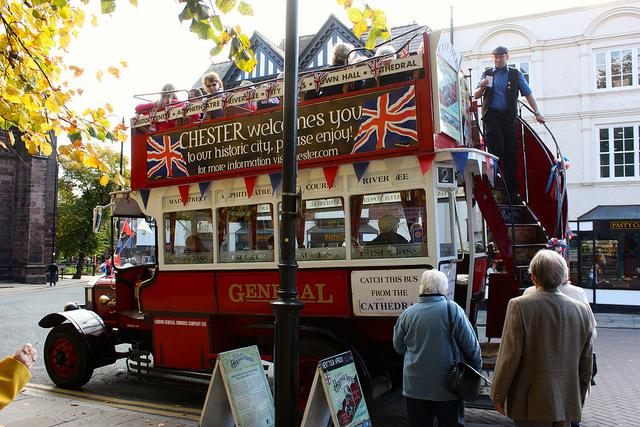The flag on the bus belongs to which Country? united kingdom 